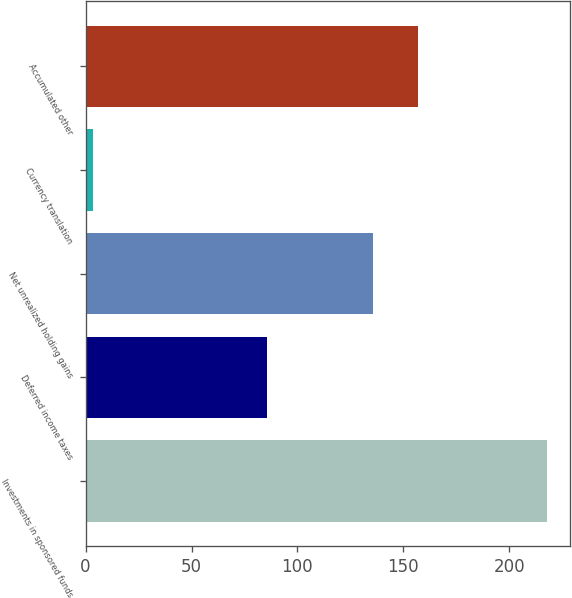Convert chart. <chart><loc_0><loc_0><loc_500><loc_500><bar_chart><fcel>Investments in sponsored funds<fcel>Deferred income taxes<fcel>Net unrealized holding gains<fcel>Currency translation<fcel>Accumulated other<nl><fcel>217.7<fcel>85.5<fcel>135.5<fcel>3.6<fcel>156.91<nl></chart> 